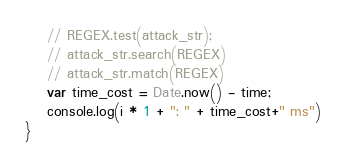Convert code to text. <code><loc_0><loc_0><loc_500><loc_500><_JavaScript_>    // REGEX.test(attack_str);
    // attack_str.search(REGEX)
    // attack_str.match(REGEX)
    var time_cost = Date.now() - time;
    console.log(i * 1 + ": " + time_cost+" ms")
}</code> 